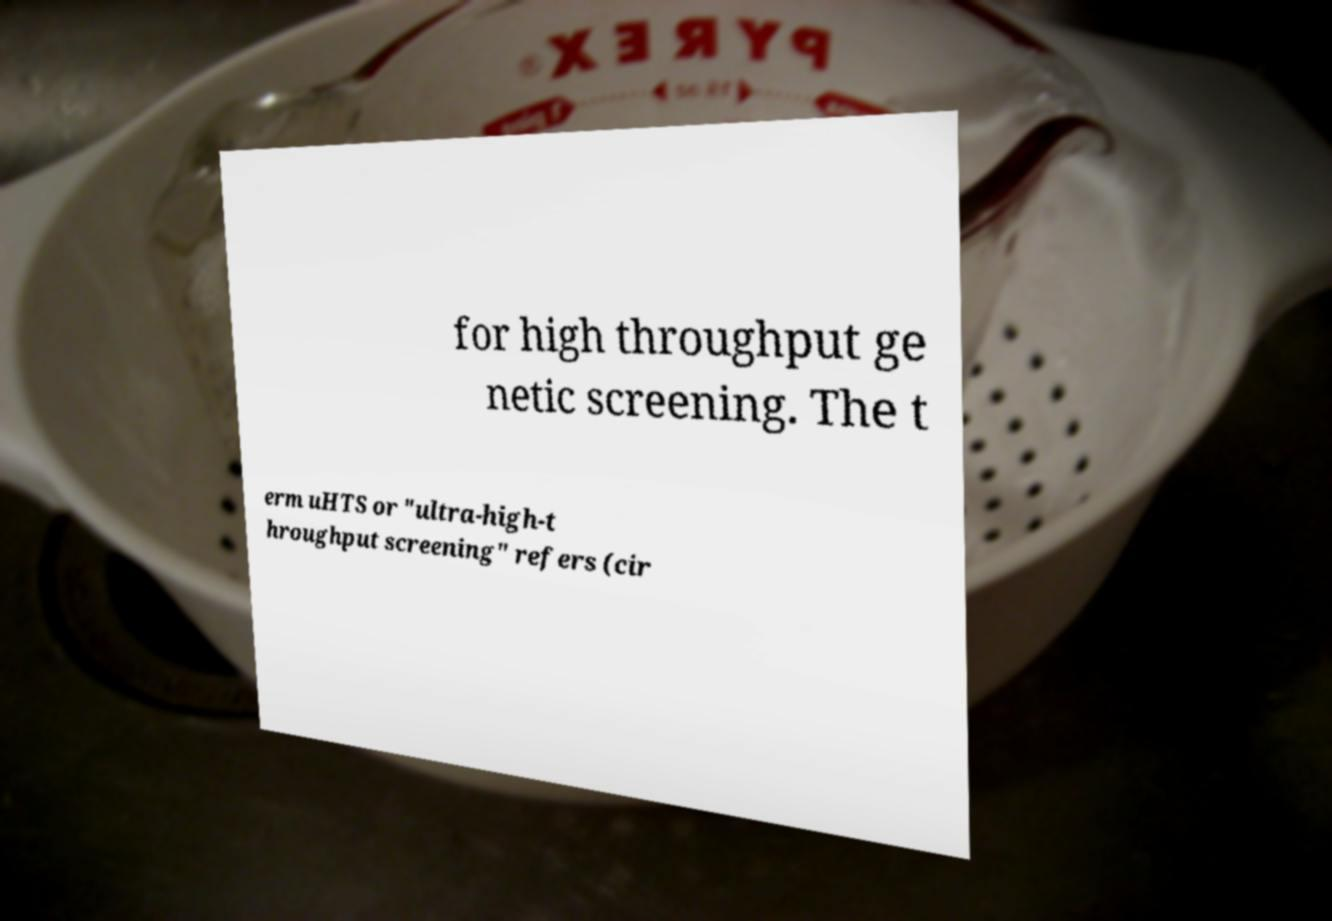Can you accurately transcribe the text from the provided image for me? for high throughput ge netic screening. The t erm uHTS or "ultra-high-t hroughput screening" refers (cir 